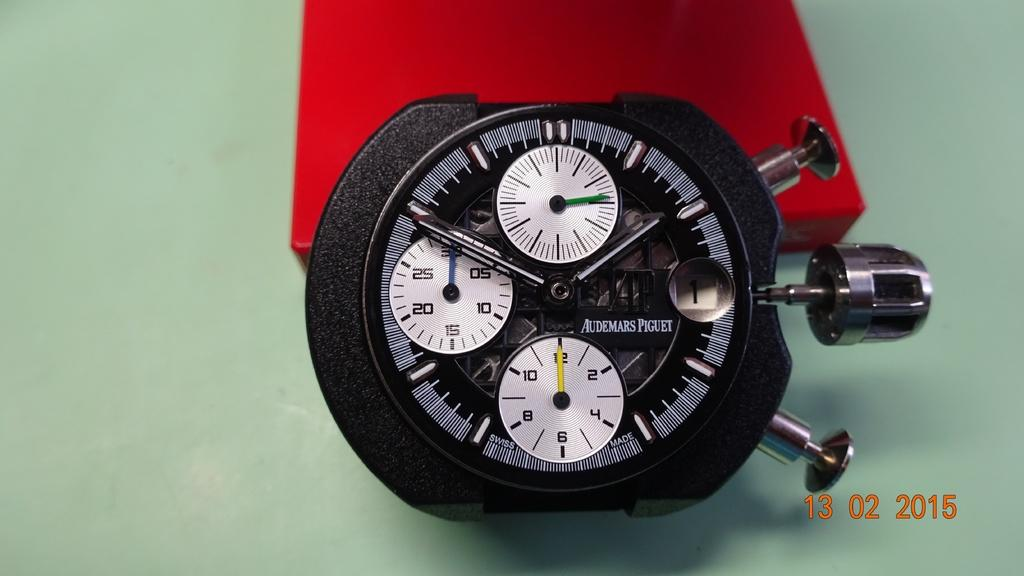<image>
Summarize the visual content of the image. A very expensive Piguet watch on top of a small red box. 